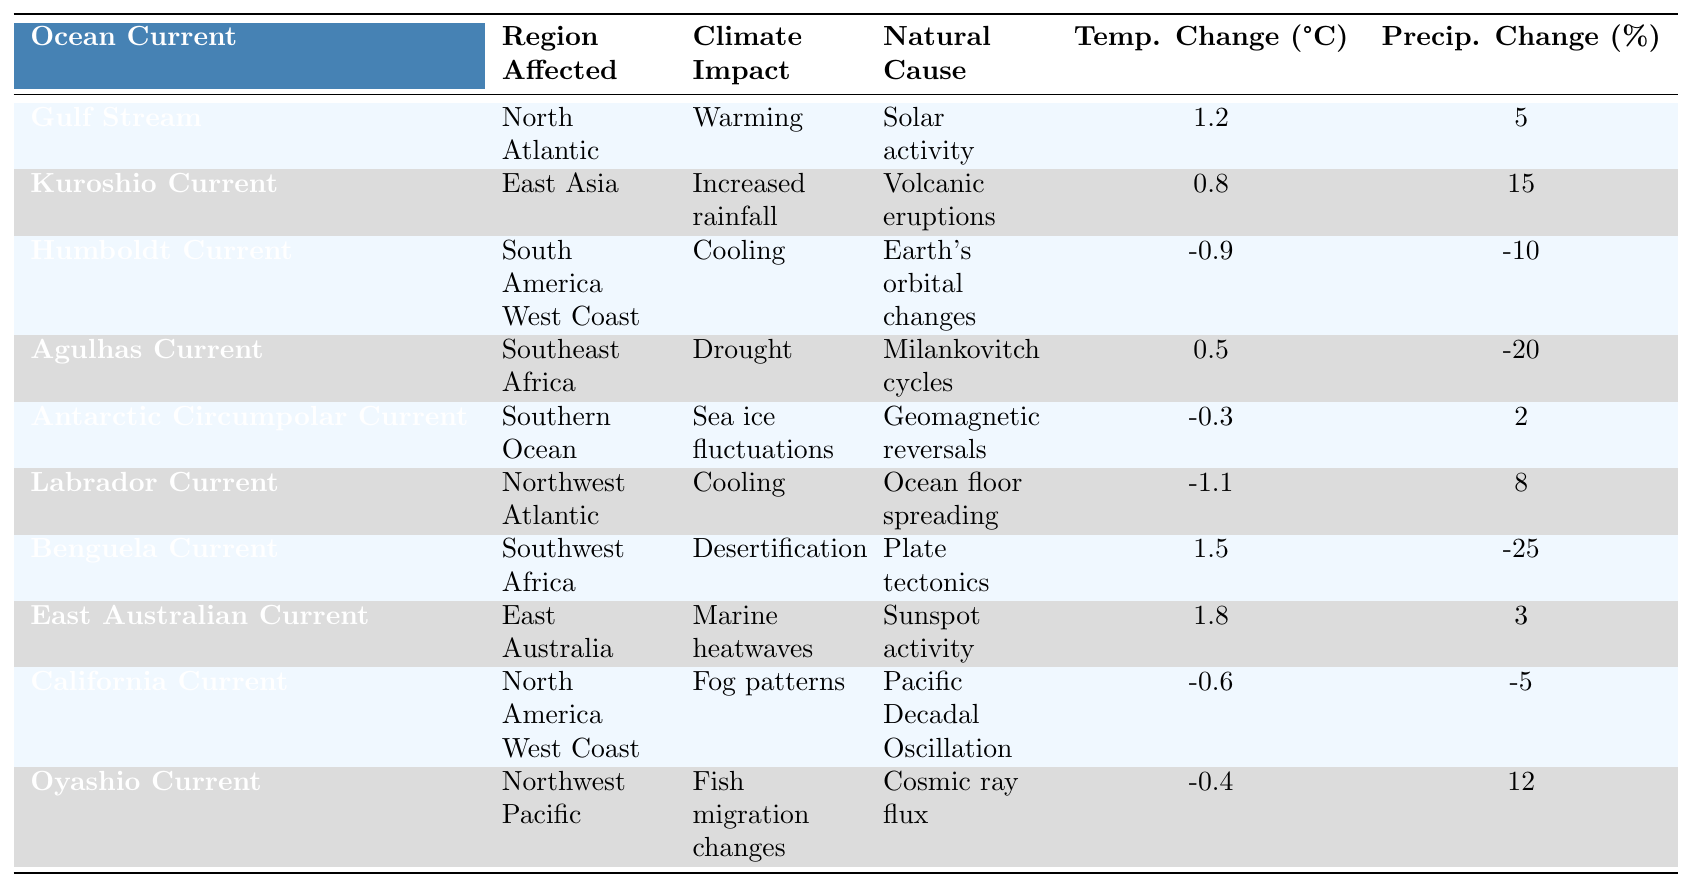What is the climate impact of the Gulf Stream? The table lists the Gulf Stream as impacting the North Atlantic with a climate impact of "Warming."
Answer: Warming Which ocean current causes increased rainfall in East Asia? The Kuroshio Current is identified in the table as the one causing increased rainfall in East Asia.
Answer: Kuroshio Current What is the temperature change associated with the Benguela Current? The temperature change for the Benguela Current, according to the table, is listed as 1.5°C.
Answer: 1.5°C How many ocean currents have a cooling impact listed in the table? The table shows two currents with a cooling impact: the Humboldt Current and the Labrador Current. Therefore, there are two currents.
Answer: 2 What is the average temperature change for the currents that are associated with cooling? The temperatures for the cooling currents are -0.9°C (Humboldt) and -1.1°C (Labrador). The average is (-0.9 + -1.1) / 2 = -1.0°C.
Answer: -1.0°C Does the Antarctic Circumpolar Current have a positive or negative temperature change? The table indicates that the Antarctic Circumpolar Current has a temperature change of -0.3°C, which is negative.
Answer: Negative Which current has the highest precipitation change percentage? The Benguela Current shows the highest precipitation change percentage at -25% according to the table.
Answer: -25% What is the relationship between the Agulhas Current and drought? The table specifies that the Agulhas Current is associated with drought in Southeast Africa, indicating an adverse climate impact.
Answer: Drought Which ocean current's impact is related to sunspot activity? The East Australian Current is linked to marine heatwaves and is associated with sunspot activity, as indicated in the table.
Answer: East Australian Current If we combine the temperature change of the Gulf Stream and the California Current, what will the result be? The temperatures are 1.2°C (Gulf Stream) and -0.6°C (California Current). The calculation is 1.2 + (-0.6) = 0.6°C.
Answer: 0.6°C 